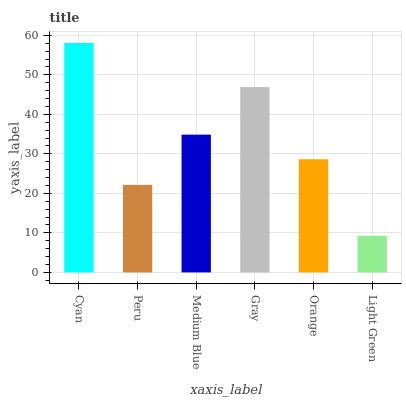Is Light Green the minimum?
Answer yes or no. Yes. Is Cyan the maximum?
Answer yes or no. Yes. Is Peru the minimum?
Answer yes or no. No. Is Peru the maximum?
Answer yes or no. No. Is Cyan greater than Peru?
Answer yes or no. Yes. Is Peru less than Cyan?
Answer yes or no. Yes. Is Peru greater than Cyan?
Answer yes or no. No. Is Cyan less than Peru?
Answer yes or no. No. Is Medium Blue the high median?
Answer yes or no. Yes. Is Orange the low median?
Answer yes or no. Yes. Is Orange the high median?
Answer yes or no. No. Is Light Green the low median?
Answer yes or no. No. 